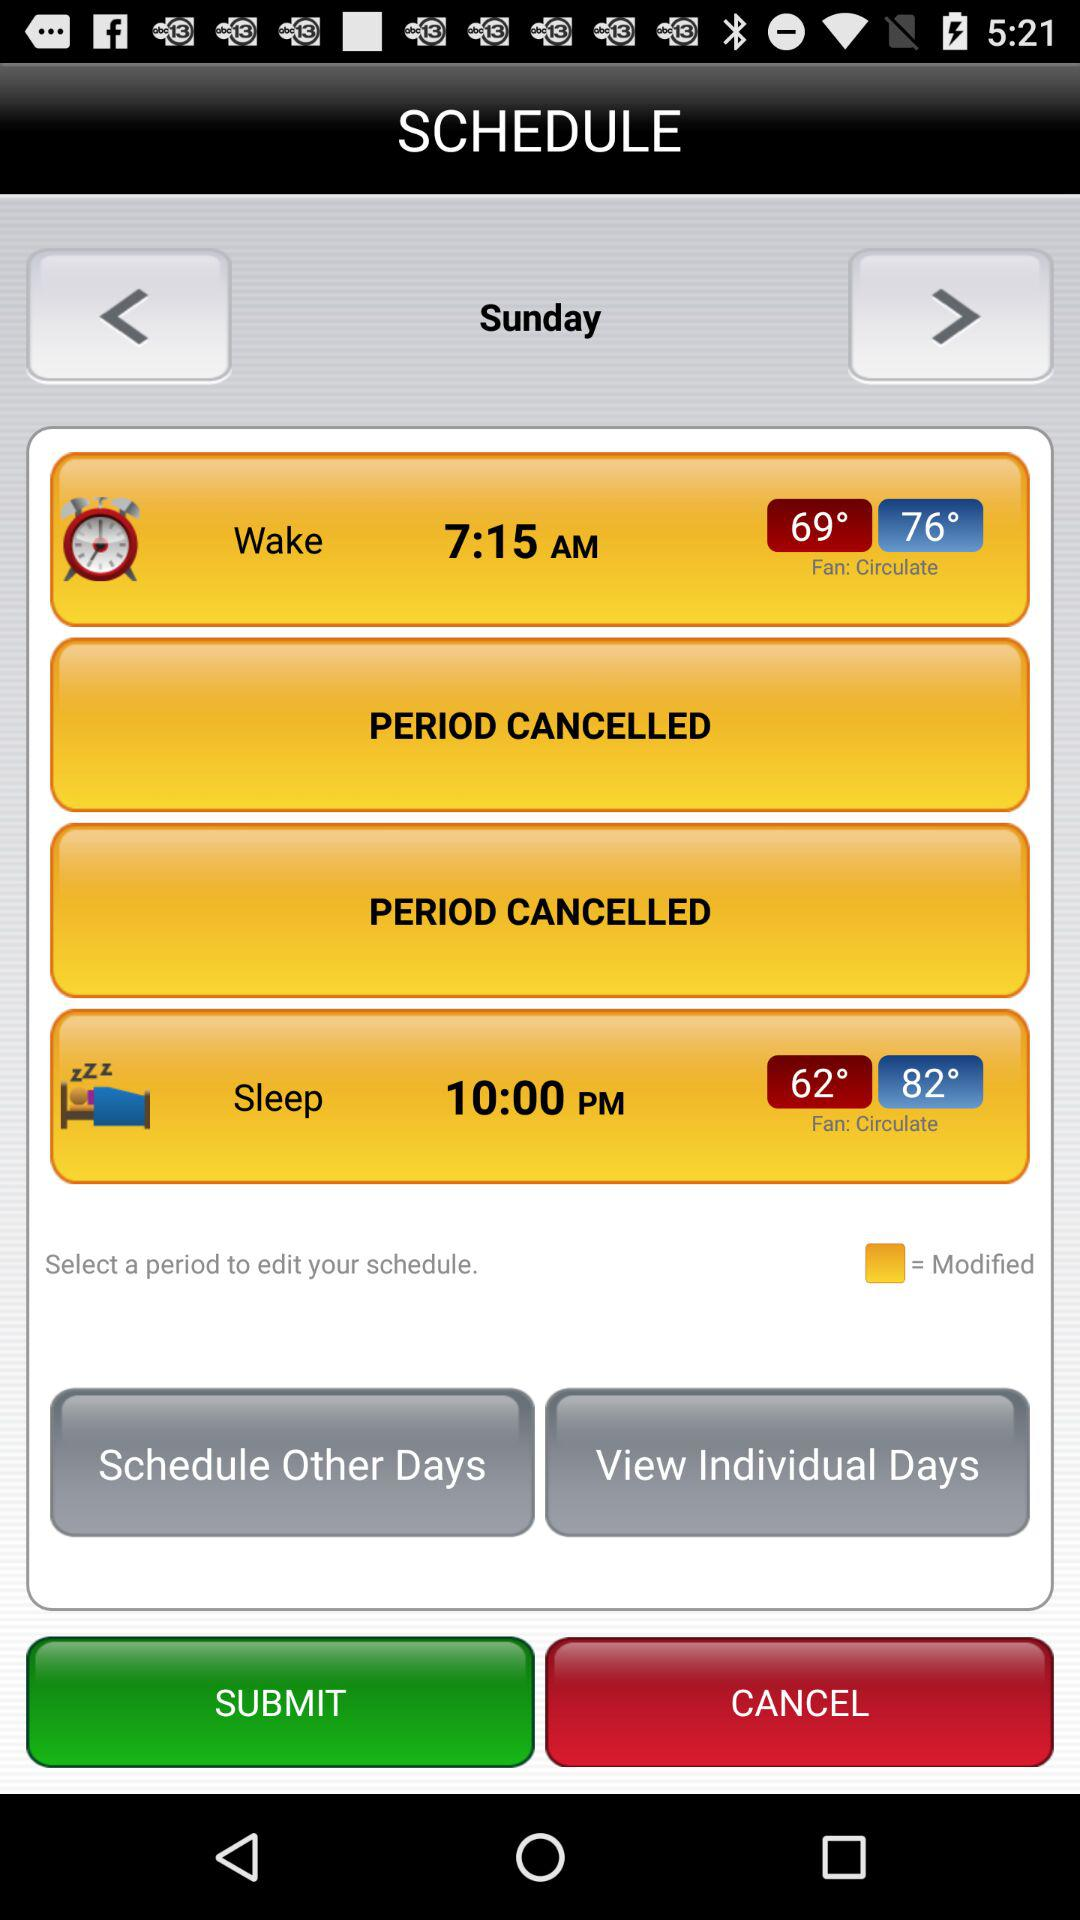What is the sleep time? The sleep time is 10:00 PM. 